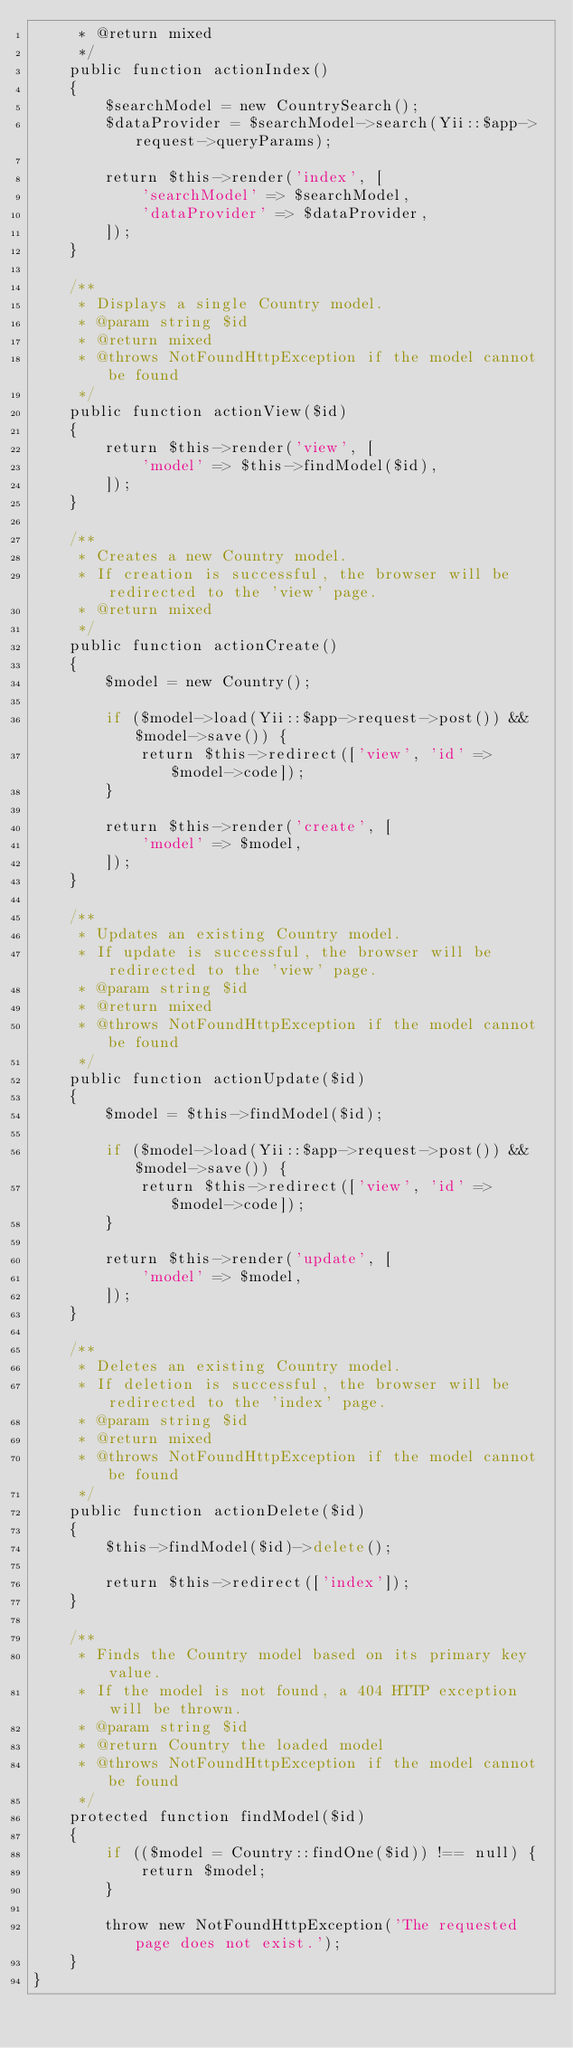<code> <loc_0><loc_0><loc_500><loc_500><_PHP_>     * @return mixed
     */
    public function actionIndex()
    {
        $searchModel = new CountrySearch();
        $dataProvider = $searchModel->search(Yii::$app->request->queryParams);

        return $this->render('index', [
            'searchModel' => $searchModel,
            'dataProvider' => $dataProvider,
        ]);
    }

    /**
     * Displays a single Country model.
     * @param string $id
     * @return mixed
     * @throws NotFoundHttpException if the model cannot be found
     */
    public function actionView($id)
    {
        return $this->render('view', [
            'model' => $this->findModel($id),
        ]);
    }

    /**
     * Creates a new Country model.
     * If creation is successful, the browser will be redirected to the 'view' page.
     * @return mixed
     */
    public function actionCreate()
    {
        $model = new Country();

        if ($model->load(Yii::$app->request->post()) && $model->save()) {
            return $this->redirect(['view', 'id' => $model->code]);
        }

        return $this->render('create', [
            'model' => $model,
        ]);
    }

    /**
     * Updates an existing Country model.
     * If update is successful, the browser will be redirected to the 'view' page.
     * @param string $id
     * @return mixed
     * @throws NotFoundHttpException if the model cannot be found
     */
    public function actionUpdate($id)
    {
        $model = $this->findModel($id);

        if ($model->load(Yii::$app->request->post()) && $model->save()) {
            return $this->redirect(['view', 'id' => $model->code]);
        }

        return $this->render('update', [
            'model' => $model,
        ]);
    }

    /**
     * Deletes an existing Country model.
     * If deletion is successful, the browser will be redirected to the 'index' page.
     * @param string $id
     * @return mixed
     * @throws NotFoundHttpException if the model cannot be found
     */
    public function actionDelete($id)
    {
        $this->findModel($id)->delete();

        return $this->redirect(['index']);
    }

    /**
     * Finds the Country model based on its primary key value.
     * If the model is not found, a 404 HTTP exception will be thrown.
     * @param string $id
     * @return Country the loaded model
     * @throws NotFoundHttpException if the model cannot be found
     */
    protected function findModel($id)
    {
        if (($model = Country::findOne($id)) !== null) {
            return $model;
        }

        throw new NotFoundHttpException('The requested page does not exist.');
    }
}
</code> 